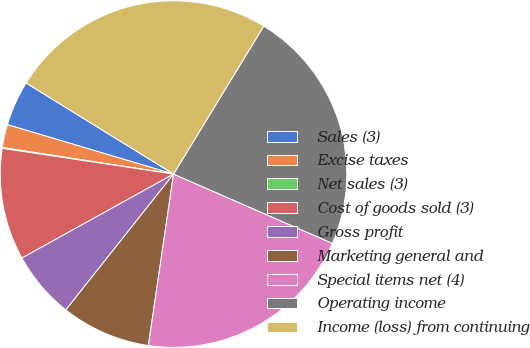Convert chart. <chart><loc_0><loc_0><loc_500><loc_500><pie_chart><fcel>Sales (3)<fcel>Excise taxes<fcel>Net sales (3)<fcel>Cost of goods sold (3)<fcel>Gross profit<fcel>Marketing general and<fcel>Special items net (4)<fcel>Operating income<fcel>Income (loss) from continuing<nl><fcel>4.21%<fcel>2.15%<fcel>0.08%<fcel>10.42%<fcel>6.28%<fcel>8.35%<fcel>20.77%<fcel>22.83%<fcel>24.9%<nl></chart> 